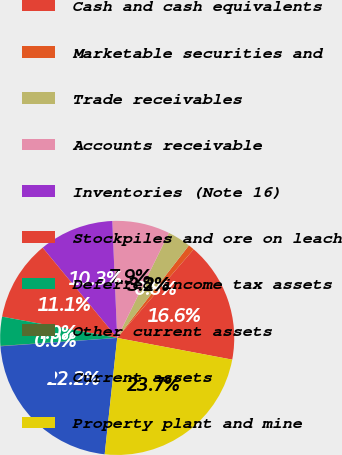Convert chart. <chart><loc_0><loc_0><loc_500><loc_500><pie_chart><fcel>Cash and cash equivalents<fcel>Marketable securities and<fcel>Trade receivables<fcel>Accounts receivable<fcel>Inventories (Note 16)<fcel>Stockpiles and ore on leach<fcel>Deferred income tax assets<fcel>Other current assets<fcel>Current assets<fcel>Property plant and mine<nl><fcel>16.64%<fcel>0.84%<fcel>3.21%<fcel>7.95%<fcel>10.32%<fcel>11.11%<fcel>4.0%<fcel>0.05%<fcel>22.16%<fcel>23.74%<nl></chart> 